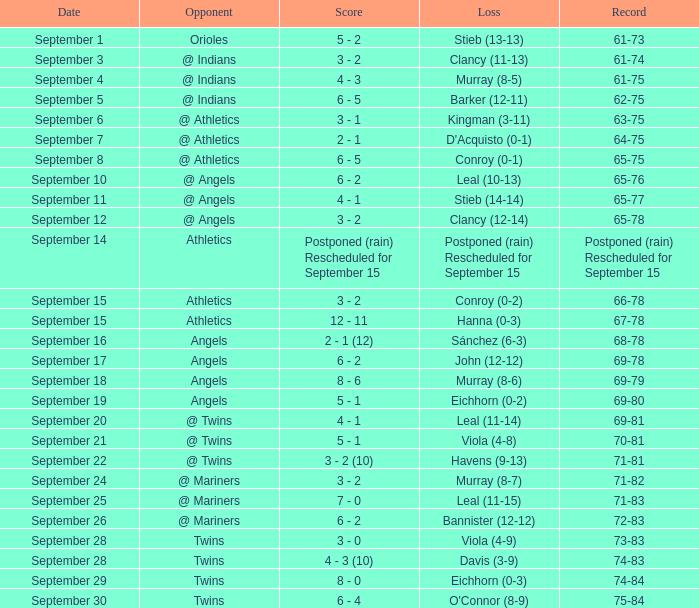On which date was the record of 74-84 documented? September 29. 